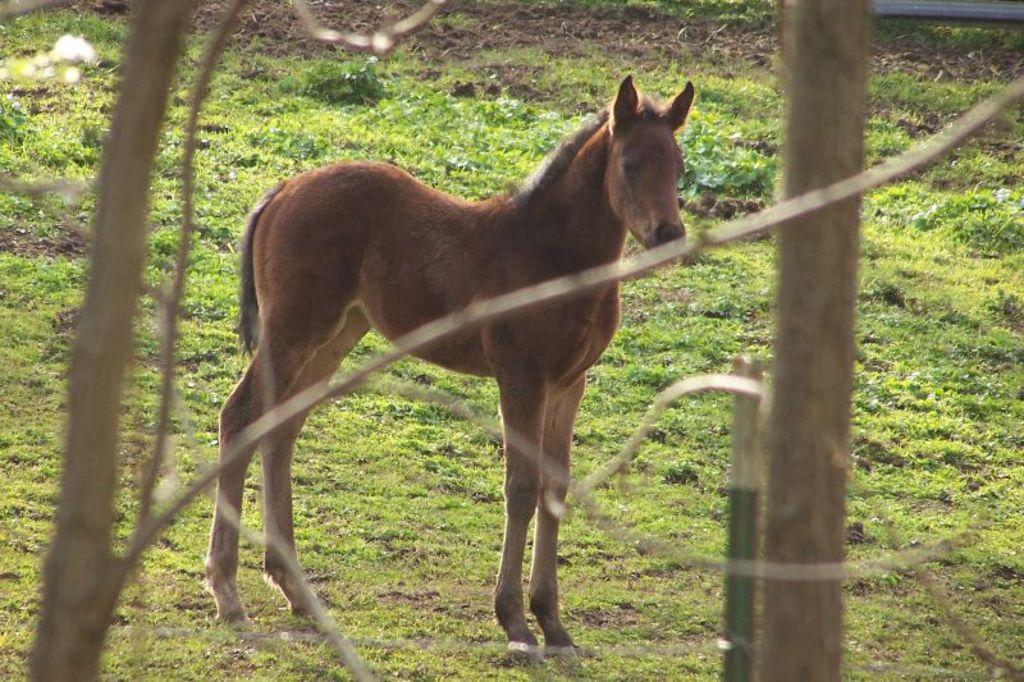What type of vegetation is present in the image? There is grass in the image. What animal can be seen in the image? There is a brown color horse in the image. What riddle does the beggar in the image pose to the box? There is no beggar or box present in the image; it only features grass and a brown color horse. 